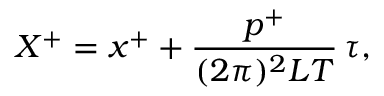<formula> <loc_0><loc_0><loc_500><loc_500>X ^ { + } = x ^ { + } + \frac { p ^ { + } } { ( 2 \pi ) ^ { 2 } L T } \, \tau ,</formula> 